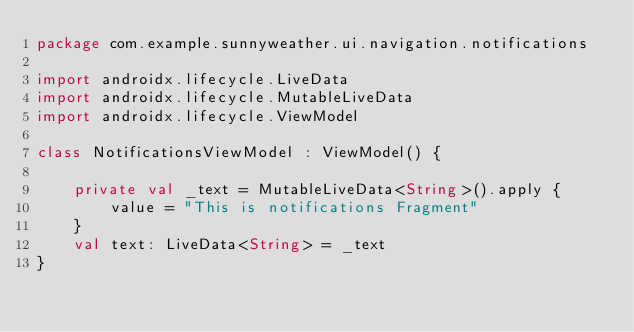Convert code to text. <code><loc_0><loc_0><loc_500><loc_500><_Kotlin_>package com.example.sunnyweather.ui.navigation.notifications

import androidx.lifecycle.LiveData
import androidx.lifecycle.MutableLiveData
import androidx.lifecycle.ViewModel

class NotificationsViewModel : ViewModel() {

    private val _text = MutableLiveData<String>().apply {
        value = "This is notifications Fragment"
    }
    val text: LiveData<String> = _text
}</code> 